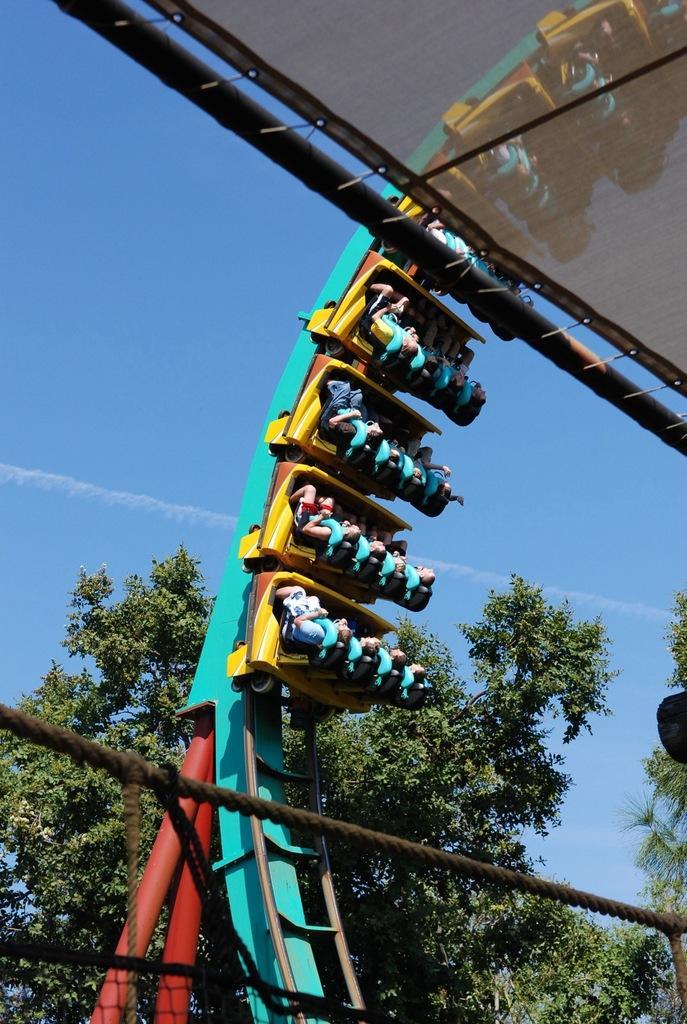Could you give a brief overview of what you see in this image? In this image we can see few persons are riding on an amusement ride. In the background there are trees and smoke in the sky. At the bottom we can see rope and a net and at the top there is a pole and a tent. 